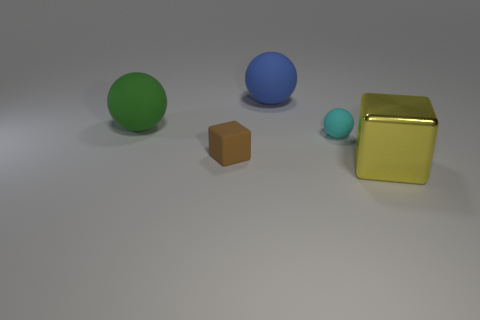Add 1 small rubber blocks. How many objects exist? 6 Subtract all cubes. How many objects are left? 3 Add 5 green balls. How many green balls are left? 6 Add 2 tiny cyan matte objects. How many tiny cyan matte objects exist? 3 Subtract 0 blue cylinders. How many objects are left? 5 Subtract all green rubber spheres. Subtract all green rubber balls. How many objects are left? 3 